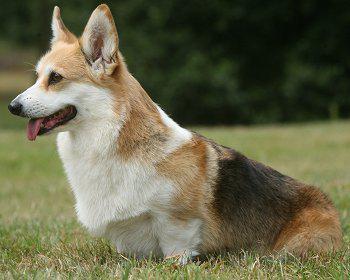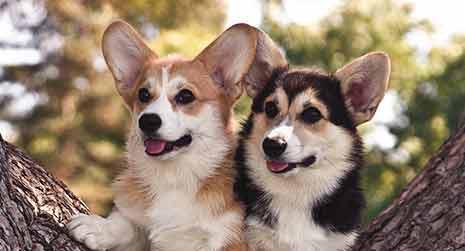The first image is the image on the left, the second image is the image on the right. Examine the images to the left and right. Is the description "One of the images shows a corgi sitting on the ground outside with its entire body visible." accurate? Answer yes or no. Yes. 